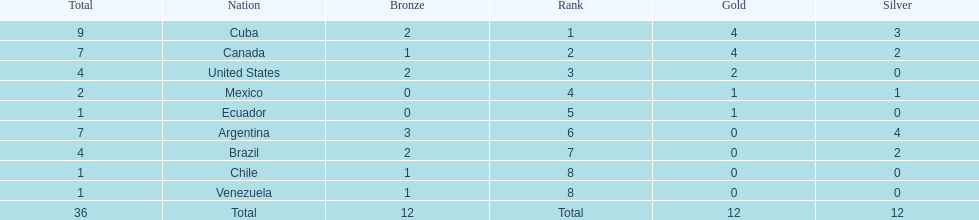Who had more silver medals, cuba or brazil? Cuba. 